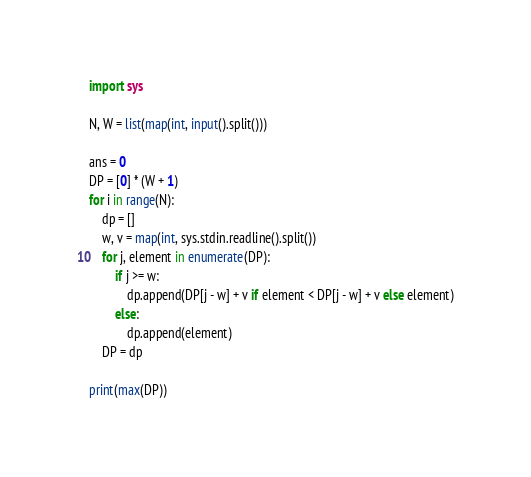Convert code to text. <code><loc_0><loc_0><loc_500><loc_500><_Python_>import sys

N, W = list(map(int, input().split()))

ans = 0
DP = [0] * (W + 1)
for i in range(N):
    dp = []
    w, v = map(int, sys.stdin.readline().split())
    for j, element in enumerate(DP):
        if j >= w:
            dp.append(DP[j - w] + v if element < DP[j - w] + v else element)
        else:
            dp.append(element)
    DP = dp

print(max(DP))
</code> 